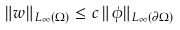<formula> <loc_0><loc_0><loc_500><loc_500>\| w \| _ { L _ { \infty } ( \Omega ) } \leq c \, \| \phi \| _ { L _ { \infty } ( \partial \Omega ) }</formula> 